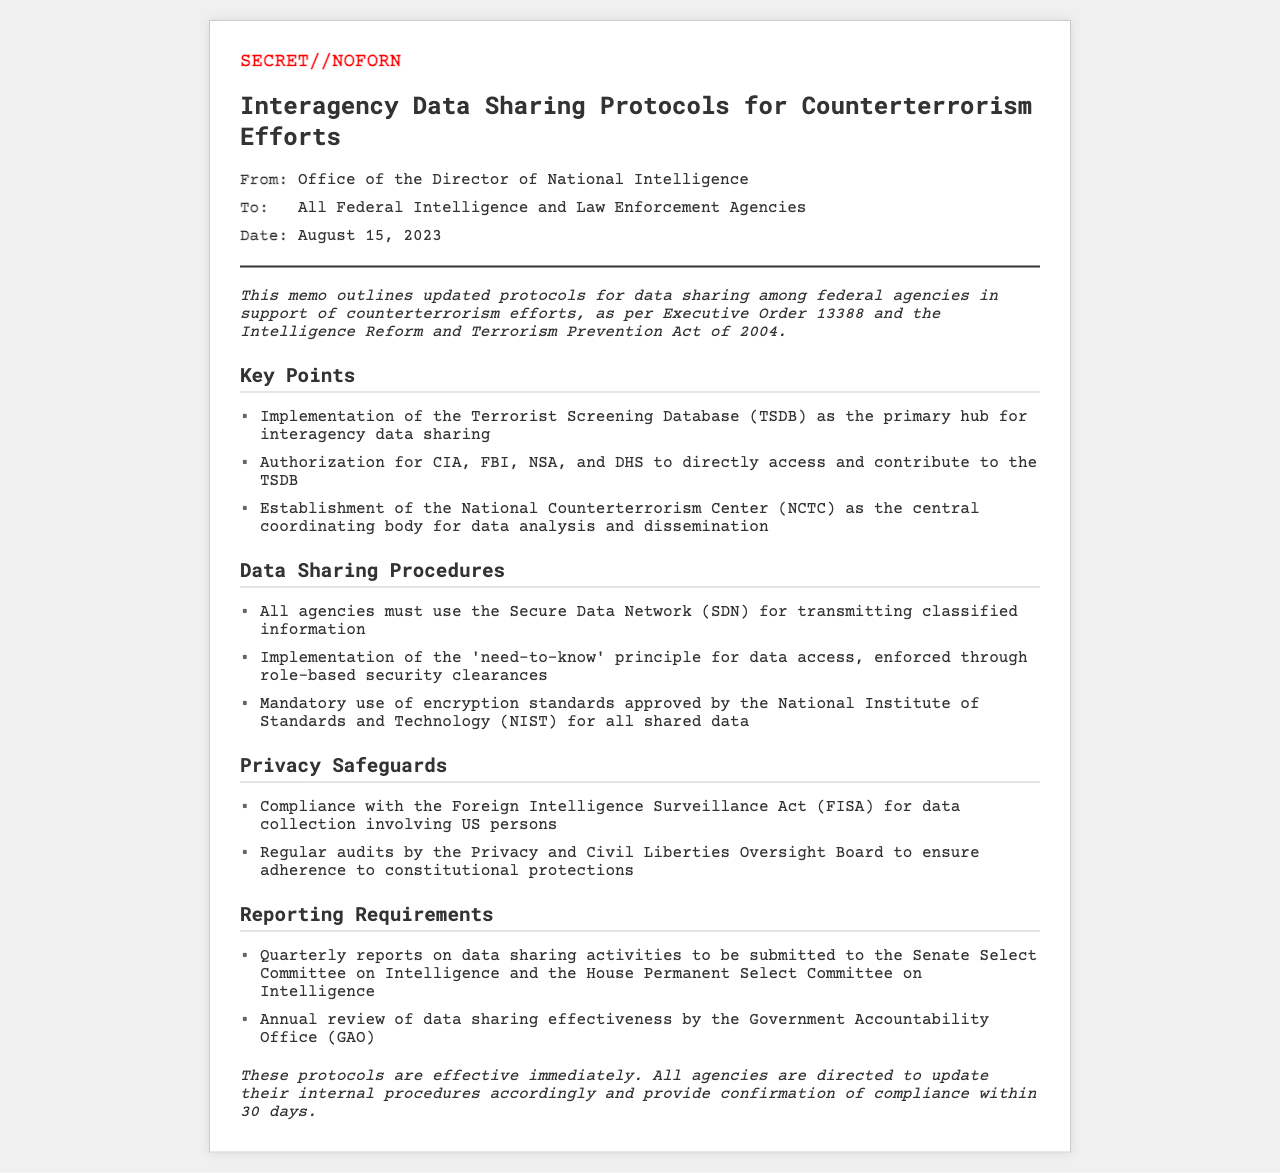What is the classification of the memo? The classification of the memo is indicated at the top, signifying its security level.
Answer: SECRET//NOFORN Who issued the memo? The memo states that it is from the Office of the Director of National Intelligence, which is responsible for its dissemination.
Answer: Office of the Director of National Intelligence What is the primary hub for interagency data sharing? The memo mentions a specific database designed for this purpose.
Answer: Terrorist Screening Database (TSDB) What is the mandatory reporting frequency for data sharing activities? The document specifies how often agencies need to submit reports related to their data sharing.
Answer: Quarterly Which act does the memo highlight for compliance regarding US persons? The memo references a legal act to be followed for matters involving US individuals during data collection.
Answer: Foreign Intelligence Surveillance Act (FISA) What is the central body for data analysis and dissemination? The memo identifies a specific center established for this role in the counterterrorism efforts.
Answer: National Counterterrorism Center (NCTC) What must all agencies use for data transmission? The document stipulates a secure network that all participating agencies are required to utilize.
Answer: Secure Data Network (SDN) Who conducts regular audits to monitor privacy safeguards? The memo mentions an entity responsible for overseeing compliance with privacy protections in data handling.
Answer: Privacy and Civil Liberties Oversight Board What are the agencies directed to provide within 30 days? The memo concludes with a directive regarding confirmation related to updated procedures.
Answer: Confirmation of compliance 